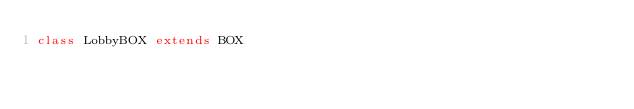Convert code to text. <code><loc_0><loc_0><loc_500><loc_500><_Scala_>class LobbyBOX extends BOX
</code> 